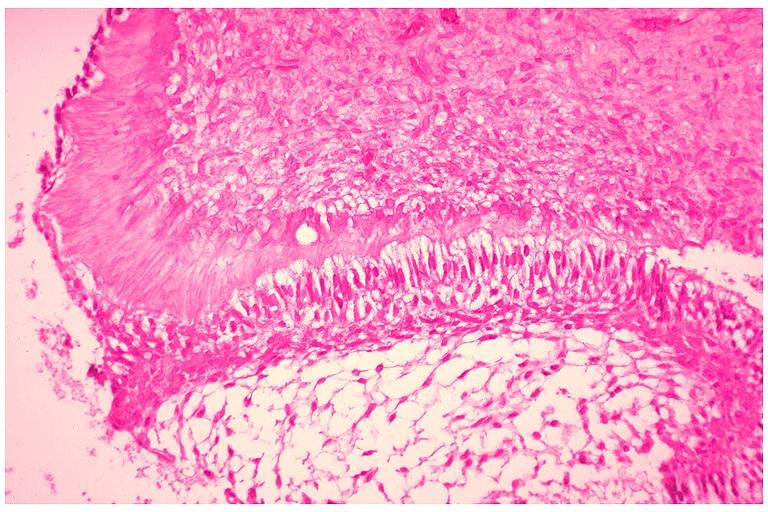does this image show developing 3rd molar?
Answer the question using a single word or phrase. Yes 